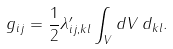Convert formula to latex. <formula><loc_0><loc_0><loc_500><loc_500>g _ { i j } = \frac { 1 } { 2 } \lambda ^ { \prime } _ { i j , k l } \int _ { V } d V \, d _ { k l } .</formula> 